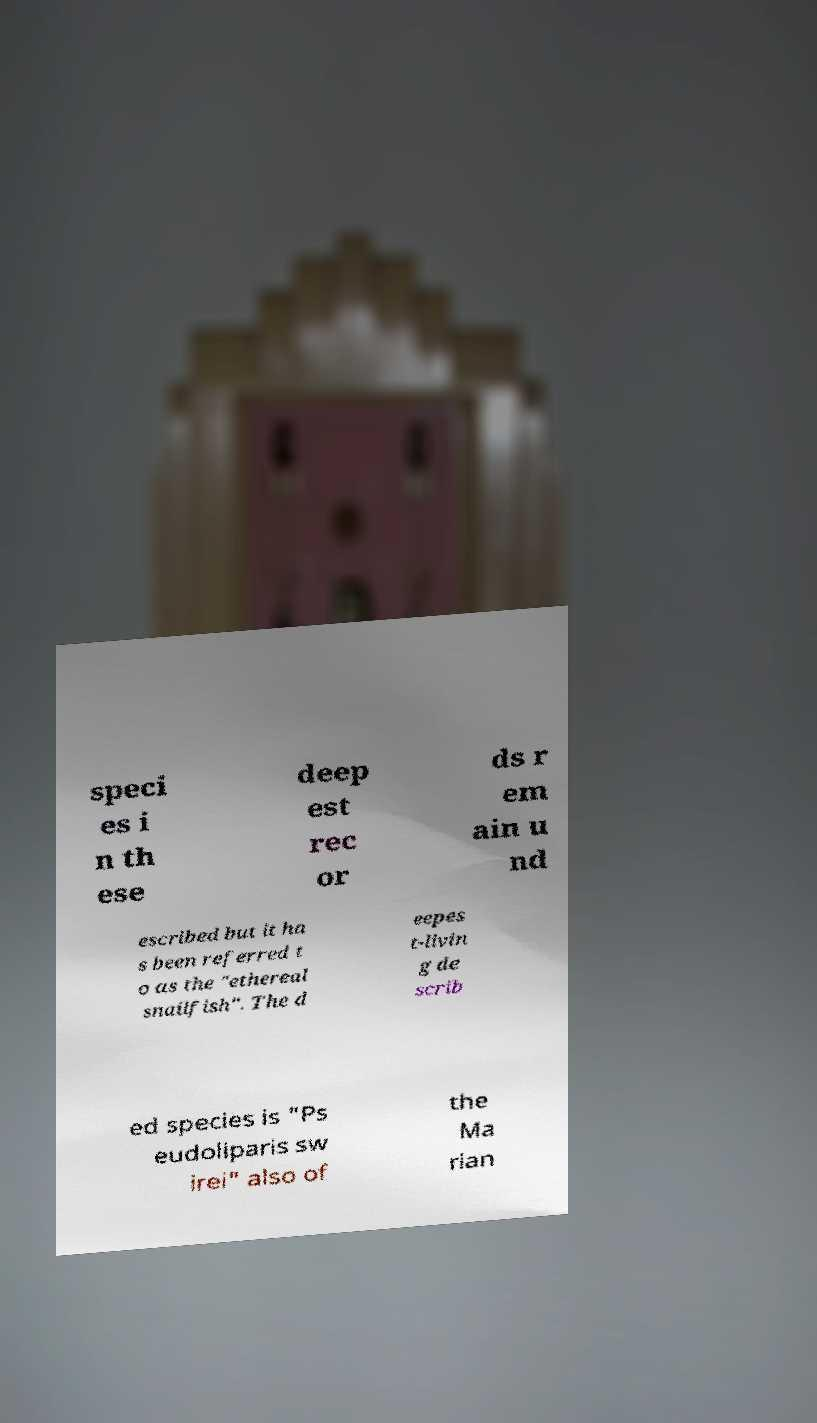I need the written content from this picture converted into text. Can you do that? speci es i n th ese deep est rec or ds r em ain u nd escribed but it ha s been referred t o as the "ethereal snailfish". The d eepes t-livin g de scrib ed species is "Ps eudoliparis sw irei" also of the Ma rian 